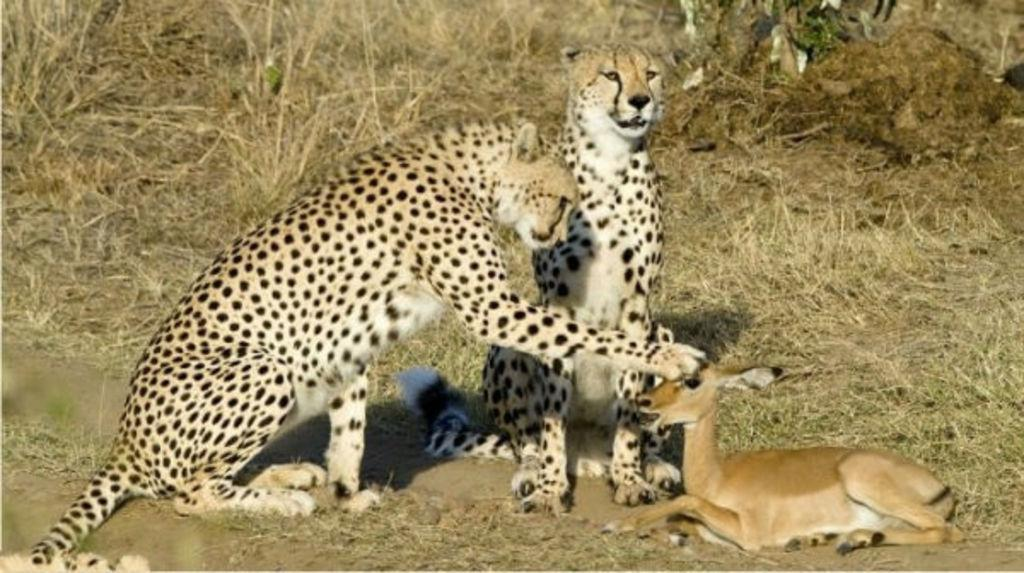What type of animals can be seen in the image? There are two cheetahs and a deer in the image. Where are the animals located? The animals are on the ground. What can be seen in the background of the image? There is dry grass visible in the background of the image. What type of laborer is working in the image? There are no laborers present in the image; it features two cheetahs and a deer. How does the deer's breath affect the image? The image does not depict the deer's breath, so it cannot be determined how it might affect the image. 